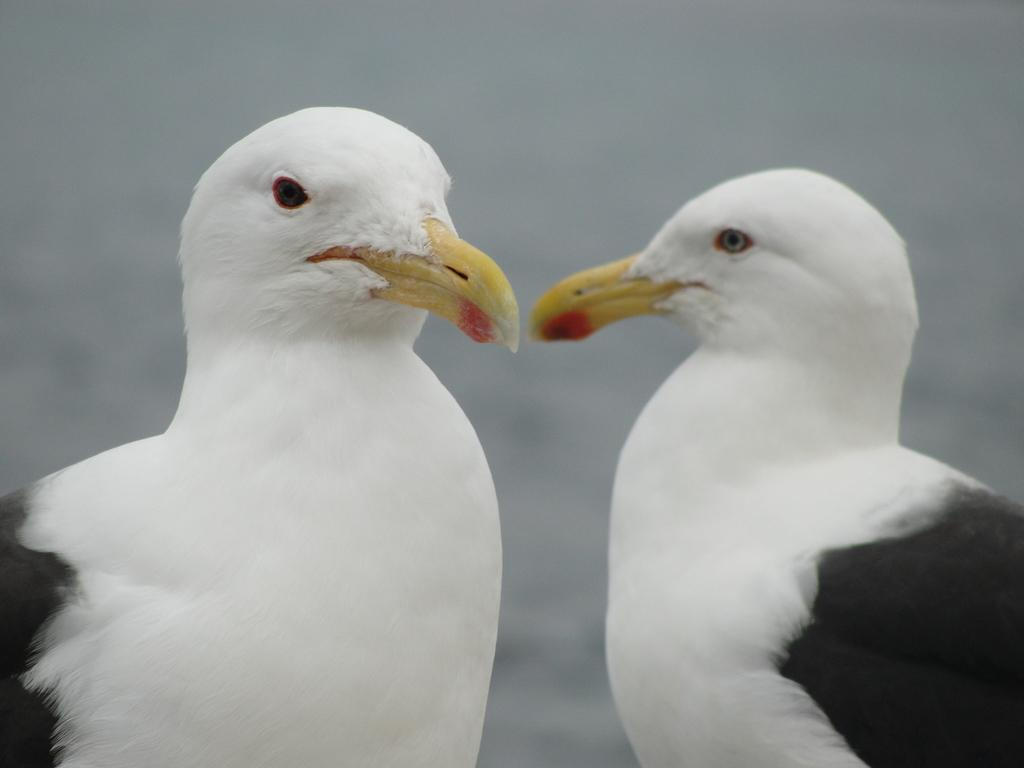How many birds are in the picture? There are two birds in the picture. What color are the birds? The birds are white in color. What other feature can be observed about the birds? The birds have black wings and yellow beaks. What type of bridge can be seen connecting the two birds in the image? There is no bridge connecting the two birds in the image; they are simply depicted as separate entities. 